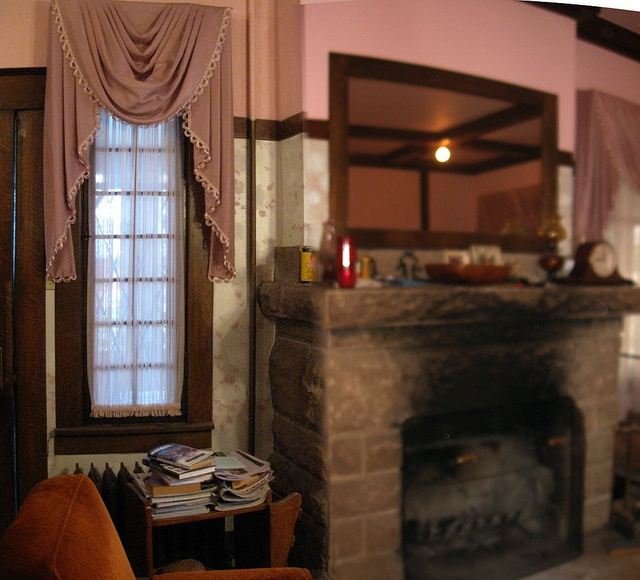Describe the objects in this image and their specific colors. I can see chair in tan, maroon, black, and brown tones, vase in tan, maroon, black, and brown tones, book in tan, gray, black, and darkgray tones, book in tan, black, brown, and maroon tones, and vase in tan, maroon, white, and brown tones in this image. 